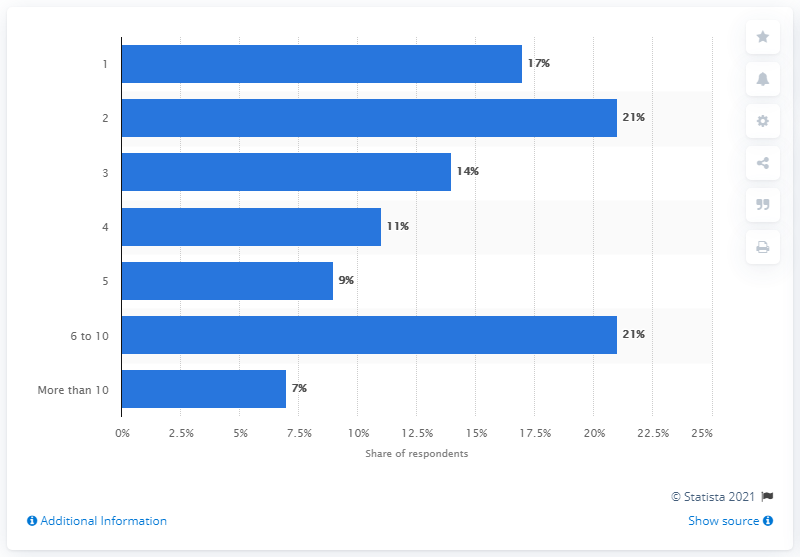Highlight a few significant elements in this photo. In the study, 7% of grandparents reported having more than 10 grandchildren. 